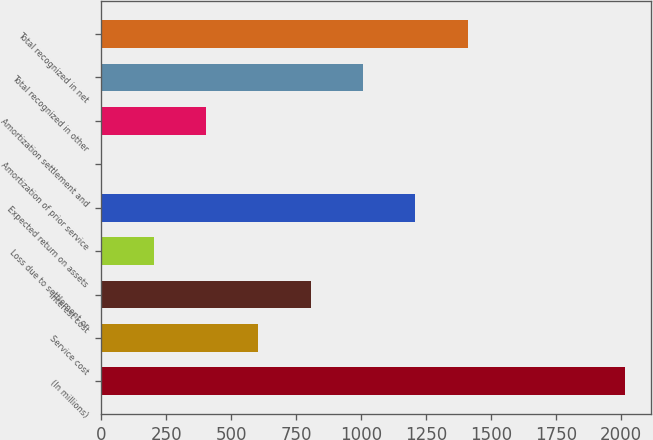Convert chart. <chart><loc_0><loc_0><loc_500><loc_500><bar_chart><fcel>(In millions)<fcel>Service cost<fcel>Interest cost<fcel>Loss due to settlement or<fcel>Expected return on assets<fcel>Amortization of prior service<fcel>Amortization settlement and<fcel>Total recognized in other<fcel>Total recognized in net<nl><fcel>2014<fcel>604.34<fcel>805.72<fcel>201.58<fcel>1208.48<fcel>0.2<fcel>402.96<fcel>1007.1<fcel>1409.86<nl></chart> 